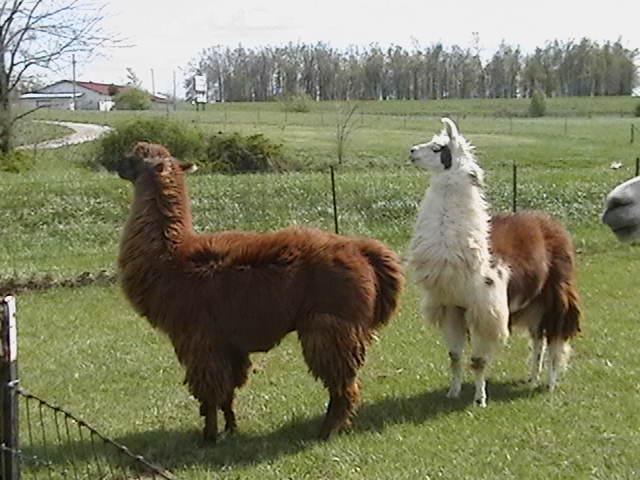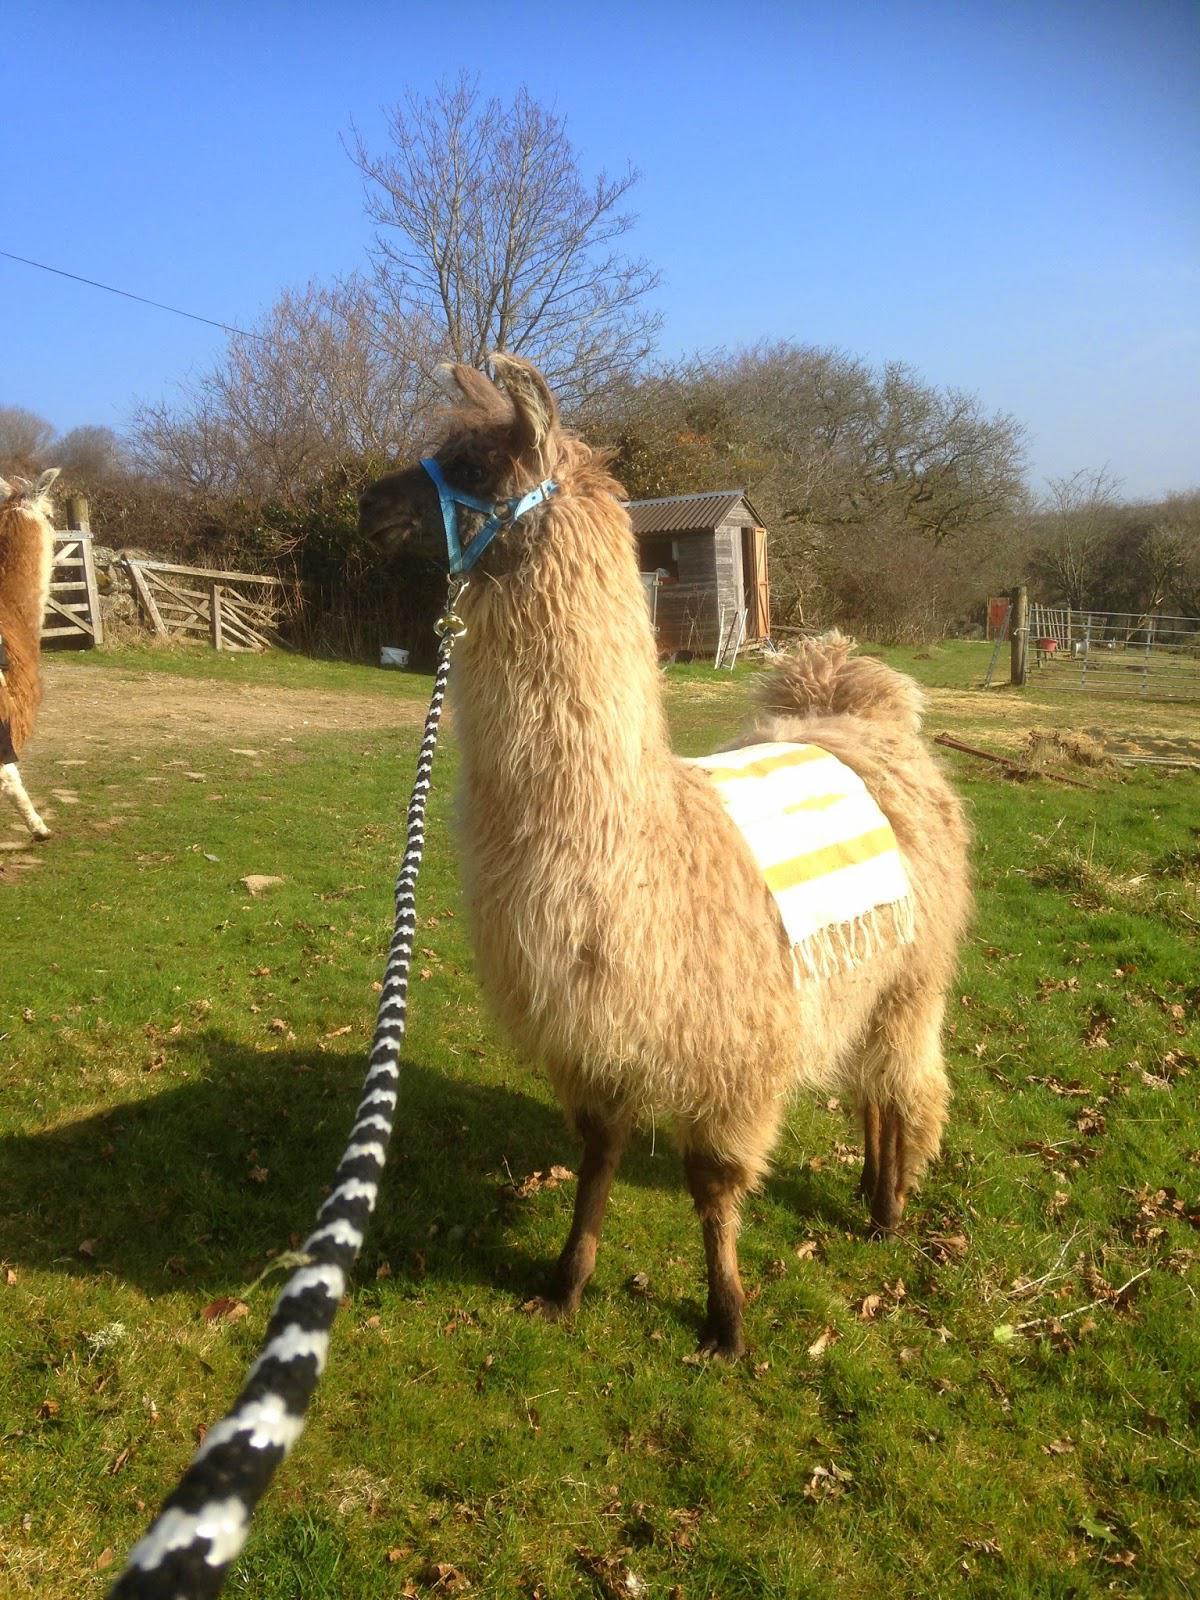The first image is the image on the left, the second image is the image on the right. Examine the images to the left and right. Is the description "The llamas in the image on the right are standing with their sides touching." accurate? Answer yes or no. No. The first image is the image on the left, the second image is the image on the right. Given the left and right images, does the statement "There are llamas next to a wire fence." hold true? Answer yes or no. Yes. 